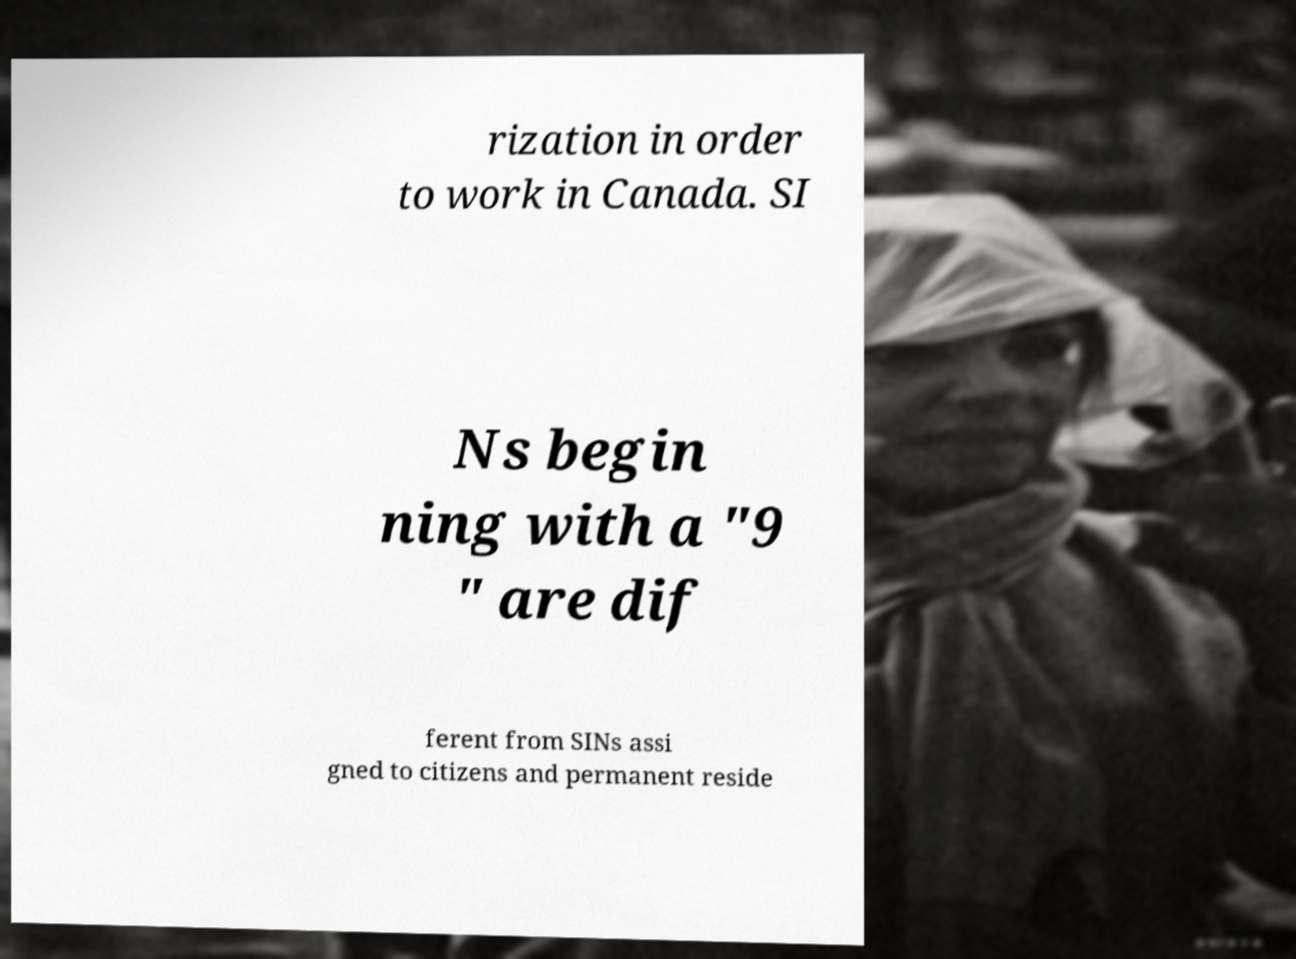Please read and relay the text visible in this image. What does it say? rization in order to work in Canada. SI Ns begin ning with a "9 " are dif ferent from SINs assi gned to citizens and permanent reside 